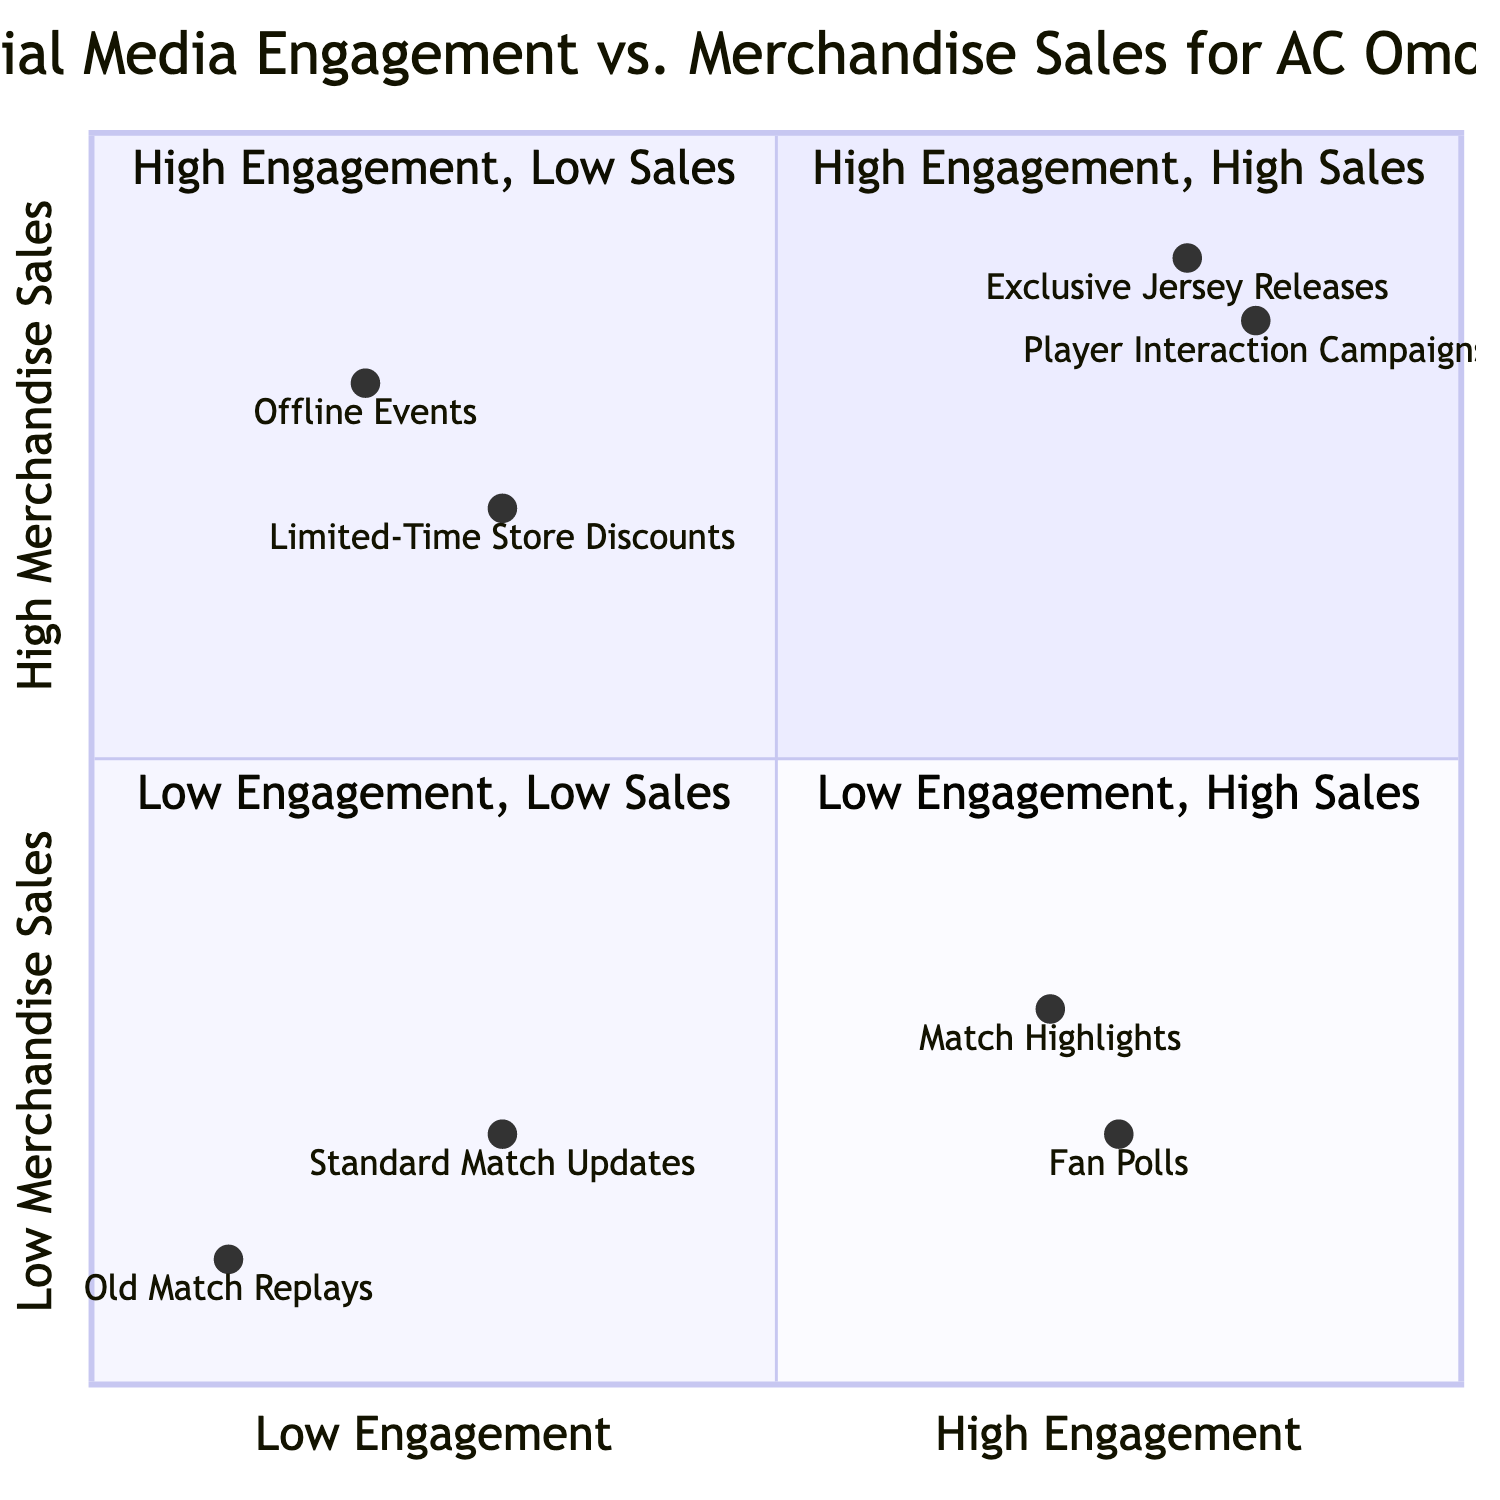What is in the High Engagement, High Merchandise Sales quadrant? The High Engagement, High Merchandise Sales quadrant includes "Exclusive Jersey Releases" and "Player Interaction Campaigns" as examples of elements that achieve high engagement and high merchandise sales.
Answer: Exclusive Jersey Releases, Player Interaction Campaigns How many examples are there in the Low Engagement, Low Merchandise Sales quadrant? In the Low Engagement, Low Merchandise Sales quadrant, there are two examples: "Standard Match Updates" and "Old Match Replays."
Answer: Two Which example has the highest engagement value? To find the highest engagement value, we compare the engagement values of all examples. "Exclusive Jersey Releases" has an engagement value of 0.8, which is the highest among all listed examples.
Answer: Exclusive Jersey Releases What is the engagement value of "Fan Polls"? The engagement value for "Fan Polls" is specified as 0.75 based on the data provided.
Answer: 0.75 Which quadrant contains "Offline Events"? "Offline Events" is located in the Low Engagement, High Merchandise Sales quadrant, which indicates it has low engagement but drives significant sales.
Answer: Low Engagement, High Merchandise Sales What is the relationship between Match Highlights and Merchandise Sales according to the diagram? "Match Highlights" is in the High Engagement, Low Merchandise Sales quadrant, indicating that while it garners high engagement, it does not significantly boost merchandise sales, defined as low sales.
Answer: High Engagement, Low Merchandise Sales Are there any examples with low engagement and high merchandise sales? Yes, in the Low Engagement, High Merchandise Sales quadrant, both "Offline Events" and "Limited-Time Store Discounts" are presented as examples.
Answer: Yes Which example has the lowest merchandise sales value? By reviewing the sales values of each example, "Old Match Replays" has the lowest merchandise sales value of 0.1.
Answer: Old Match Replays 